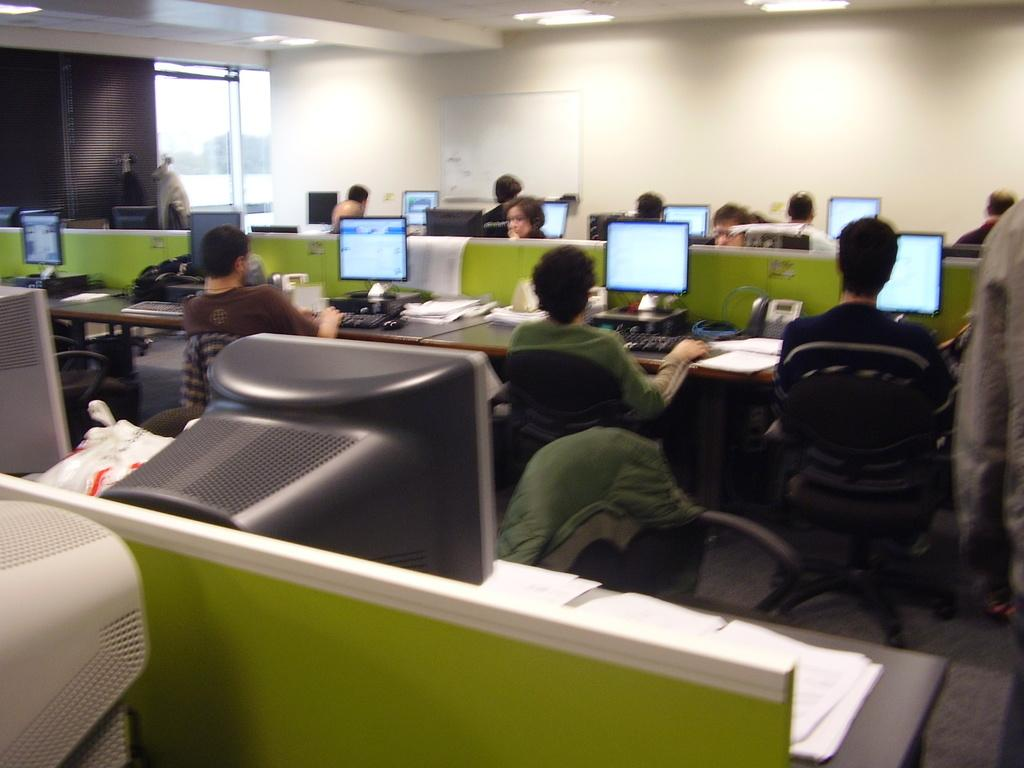What is happening in the image involving a group of people? There is a group of people in the image, and they are sitting in chairs. What are the people doing while sitting in the chairs? The people are operating computers in the image. Where are the computers located in relation to the people? The computers are on a table in front of the people. How many pages can be seen in the image? There is no mention of pages in the provided facts, so it cannot be determined from the image. 